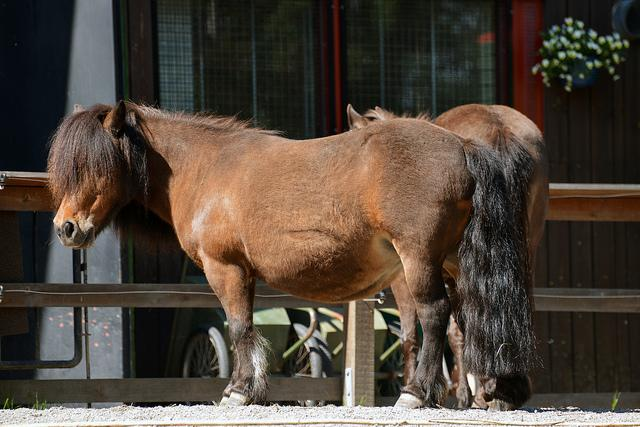What type of horse is this?

Choices:
A) arabian
B) shetland pony
C) clydesdale
D) mustang shetland pony 